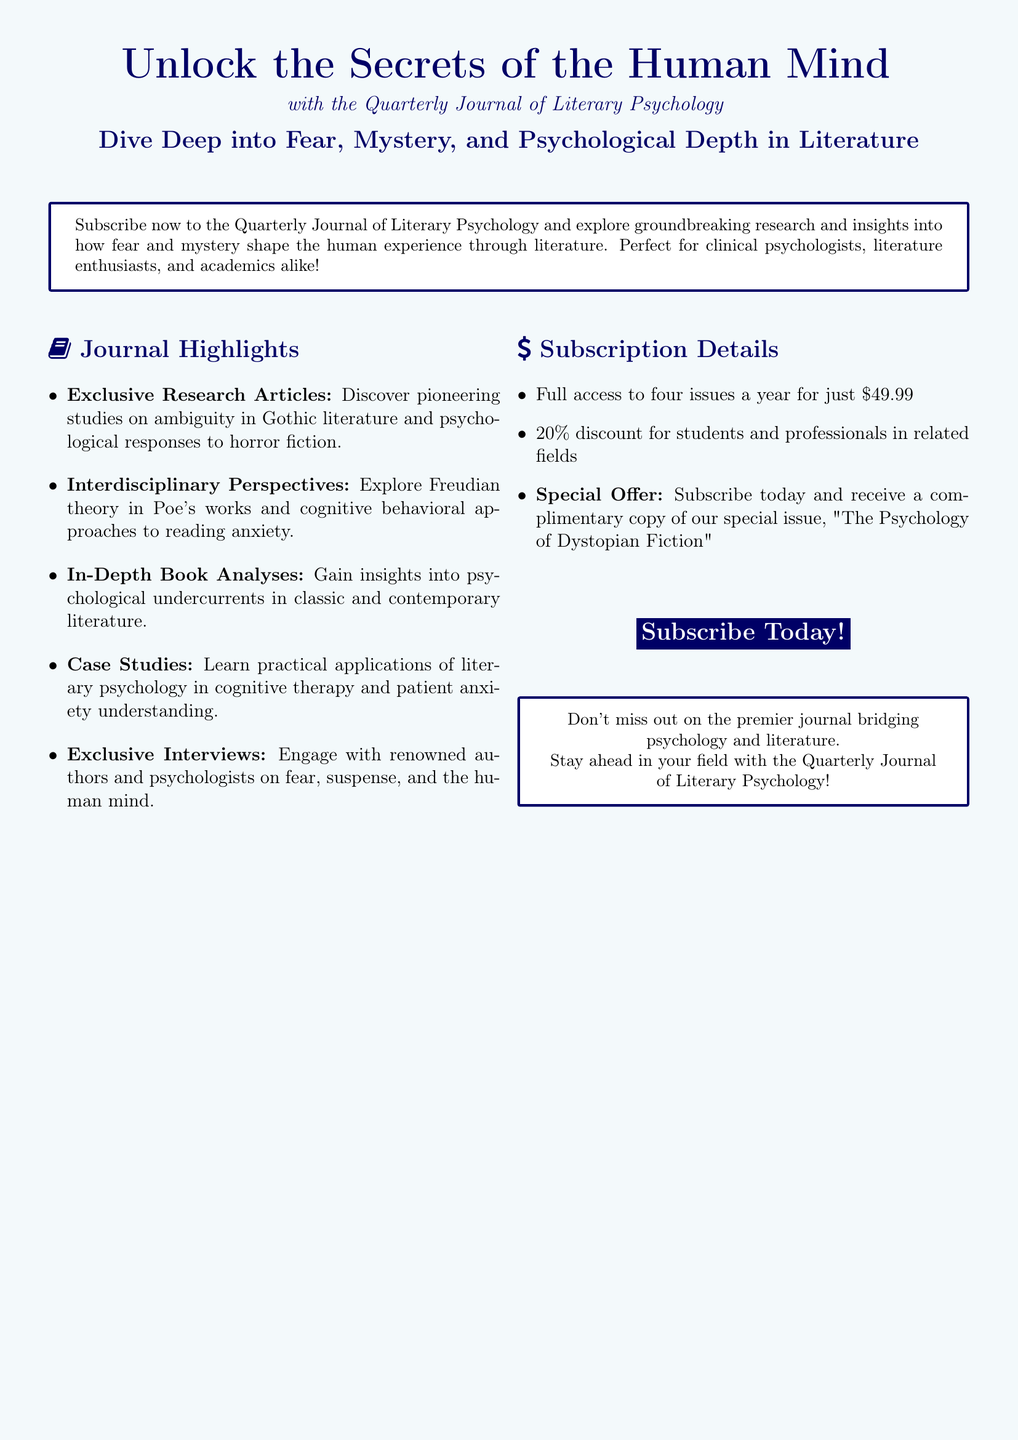What is the cost for four issues of the journal? The document states that the cost for full access to four issues a year is $49.99.
Answer: $49.99 What special offer is mentioned? The document highlights a special offer of receiving a complimentary copy of the special issue "The Psychology of Dystopian Fiction" upon subscription.
Answer: Complimentary copy of "The Psychology of Dystopian Fiction" Who are the intended audiences for the journal? The advertisement identifies clinical psychologists, literature enthusiasts, and academics as the intended audiences.
Answer: Clinical psychologists, literature enthusiasts, and academics What percentage discount do students receive? The document states that students receive a 20% discount for subscribing to the journal.
Answer: 20% Name one type of article featured in the journal. The journal features exclusive research articles that include pioneering studies on ambiguity in Gothic literature and psychological responses to horror fiction.
Answer: Exclusive research articles Which psychological theory is explored in relation to Poe's works? The advertisement mentions the exploration of Freudian theory in the context of Poe's works.
Answer: Freudian theory What color is used for the journal highlights section? The highlights section in the advertisement utilizes a dark blue color.
Answer: Dark blue What can readers expect to engage with in the journal? Readers can expect to engage with renowned authors and psychologists on topics related to fear, suspense, and the human mind.
Answer: Renowned authors and psychologists 